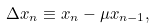<formula> <loc_0><loc_0><loc_500><loc_500>\Delta x _ { n } \equiv x _ { n } - \mu x _ { n - 1 } ,</formula> 